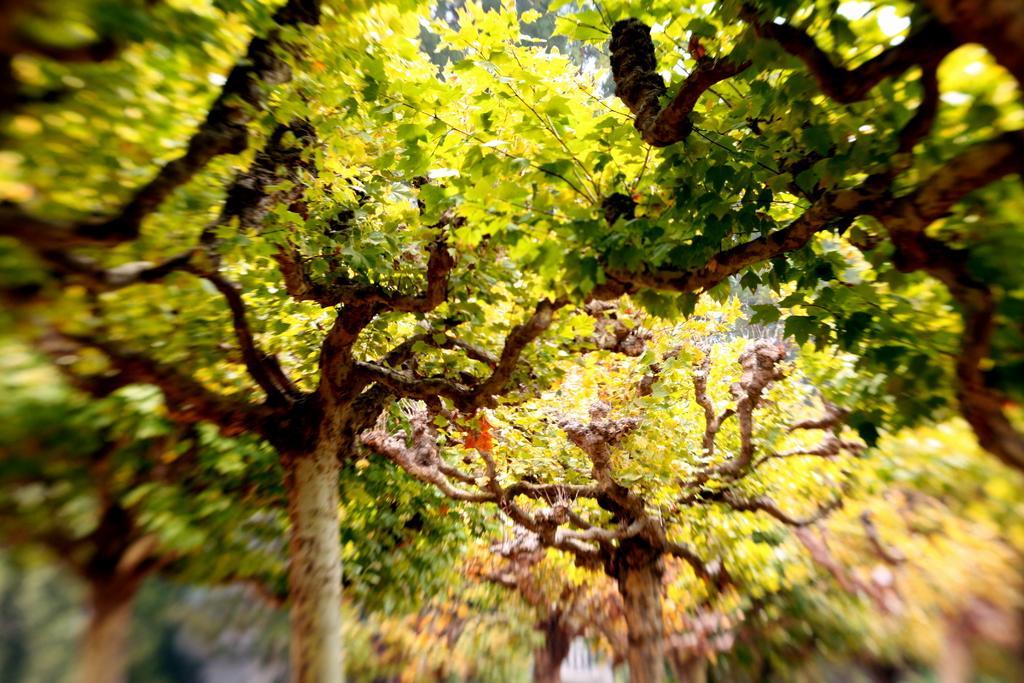How would you summarize this image in a sentence or two? In this image there are trees truncated, the bottom of the image is blurred. 